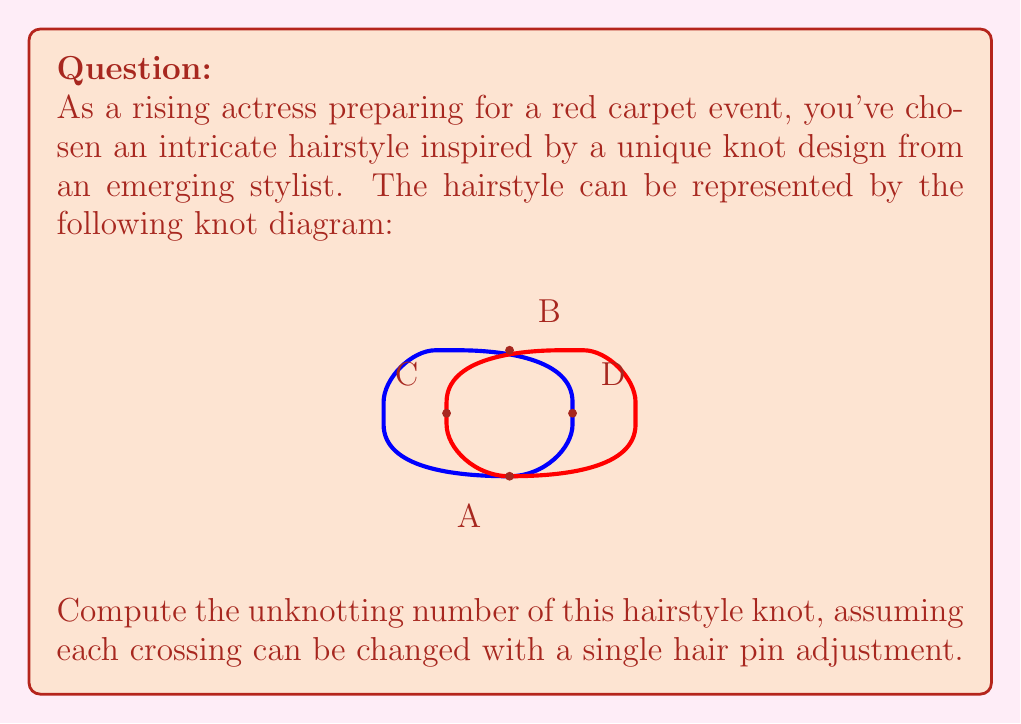Show me your answer to this math problem. To solve this problem, we need to follow these steps:

1) First, let's recall that the unknotting number of a knot is the minimum number of crossing changes needed to transform the knot into the unknot (trivial knot).

2) Observe the given knot diagram. It appears to be a variation of the figure-eight knot, which is known to have an unknotting number of 1.

3) To confirm this, let's analyze the crossings:
   - There are 4 crossings in total: A, B, C, and D.
   
4) To unknot this hairstyle, we need to find the most efficient way to change crossings:
   
   a) If we change the crossing at point A:
      $$\text{A} \rightarrow \text{unknot}$$
      
   b) Changing any other single crossing doesn't lead to the unknot:
      $$\text{B or C or D} \not\rightarrow \text{unknot}$$
      
5) Therefore, changing the crossing at point A is sufficient to unknot the hairstyle.

6) This means that only one "hair pin adjustment" (crossing change) is needed to transform this knot into the unknot.

7) By definition, the unknotting number is the minimum number of such changes required, which in this case is 1.
Answer: 1 